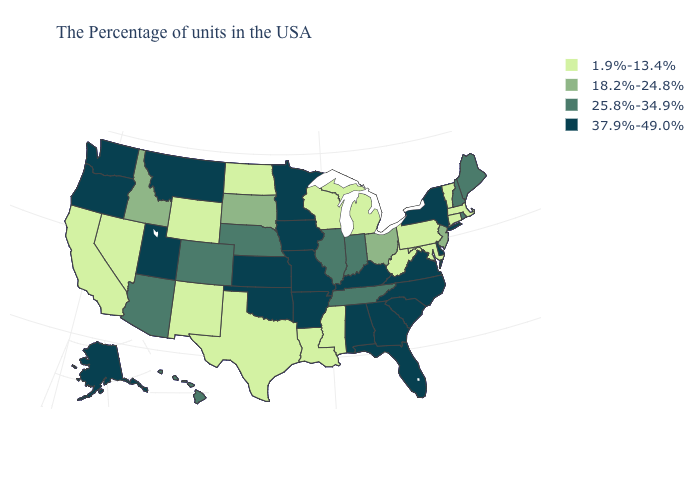Name the states that have a value in the range 37.9%-49.0%?
Concise answer only. New York, Delaware, Virginia, North Carolina, South Carolina, Florida, Georgia, Kentucky, Alabama, Missouri, Arkansas, Minnesota, Iowa, Kansas, Oklahoma, Utah, Montana, Washington, Oregon, Alaska. What is the value of Wisconsin?
Be succinct. 1.9%-13.4%. Does the map have missing data?
Concise answer only. No. Among the states that border Maryland , which have the highest value?
Write a very short answer. Delaware, Virginia. Name the states that have a value in the range 37.9%-49.0%?
Short answer required. New York, Delaware, Virginia, North Carolina, South Carolina, Florida, Georgia, Kentucky, Alabama, Missouri, Arkansas, Minnesota, Iowa, Kansas, Oklahoma, Utah, Montana, Washington, Oregon, Alaska. Name the states that have a value in the range 18.2%-24.8%?
Be succinct. New Jersey, Ohio, South Dakota, Idaho. Is the legend a continuous bar?
Short answer required. No. Does West Virginia have a higher value than Florida?
Short answer required. No. Among the states that border California , which have the lowest value?
Quick response, please. Nevada. Does North Carolina have the lowest value in the South?
Give a very brief answer. No. Does New York have the highest value in the USA?
Keep it brief. Yes. Which states have the highest value in the USA?
Quick response, please. New York, Delaware, Virginia, North Carolina, South Carolina, Florida, Georgia, Kentucky, Alabama, Missouri, Arkansas, Minnesota, Iowa, Kansas, Oklahoma, Utah, Montana, Washington, Oregon, Alaska. What is the value of South Dakota?
Be succinct. 18.2%-24.8%. Among the states that border New Hampshire , which have the lowest value?
Answer briefly. Massachusetts, Vermont. Does Vermont have a higher value than Nebraska?
Short answer required. No. 